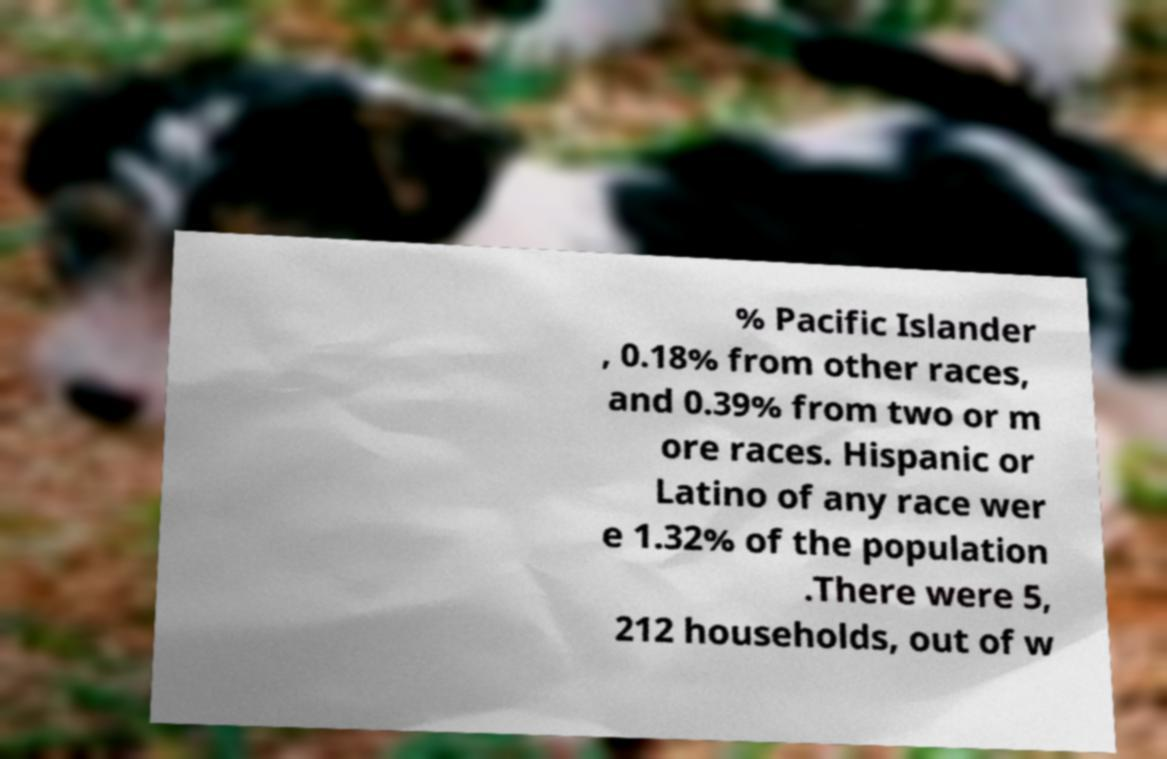Can you read and provide the text displayed in the image?This photo seems to have some interesting text. Can you extract and type it out for me? % Pacific Islander , 0.18% from other races, and 0.39% from two or m ore races. Hispanic or Latino of any race wer e 1.32% of the population .There were 5, 212 households, out of w 